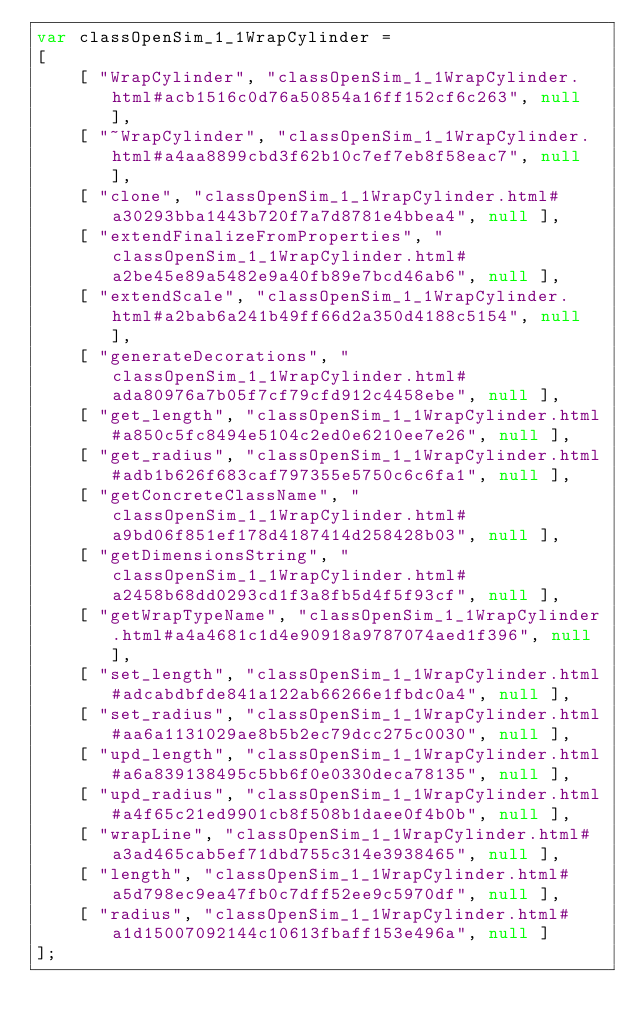<code> <loc_0><loc_0><loc_500><loc_500><_JavaScript_>var classOpenSim_1_1WrapCylinder =
[
    [ "WrapCylinder", "classOpenSim_1_1WrapCylinder.html#acb1516c0d76a50854a16ff152cf6c263", null ],
    [ "~WrapCylinder", "classOpenSim_1_1WrapCylinder.html#a4aa8899cbd3f62b10c7ef7eb8f58eac7", null ],
    [ "clone", "classOpenSim_1_1WrapCylinder.html#a30293bba1443b720f7a7d8781e4bbea4", null ],
    [ "extendFinalizeFromProperties", "classOpenSim_1_1WrapCylinder.html#a2be45e89a5482e9a40fb89e7bcd46ab6", null ],
    [ "extendScale", "classOpenSim_1_1WrapCylinder.html#a2bab6a241b49ff66d2a350d4188c5154", null ],
    [ "generateDecorations", "classOpenSim_1_1WrapCylinder.html#ada80976a7b05f7cf79cfd912c4458ebe", null ],
    [ "get_length", "classOpenSim_1_1WrapCylinder.html#a850c5fc8494e5104c2ed0e6210ee7e26", null ],
    [ "get_radius", "classOpenSim_1_1WrapCylinder.html#adb1b626f683caf797355e5750c6c6fa1", null ],
    [ "getConcreteClassName", "classOpenSim_1_1WrapCylinder.html#a9bd06f851ef178d4187414d258428b03", null ],
    [ "getDimensionsString", "classOpenSim_1_1WrapCylinder.html#a2458b68dd0293cd1f3a8fb5d4f5f93cf", null ],
    [ "getWrapTypeName", "classOpenSim_1_1WrapCylinder.html#a4a4681c1d4e90918a9787074aed1f396", null ],
    [ "set_length", "classOpenSim_1_1WrapCylinder.html#adcabdbfde841a122ab66266e1fbdc0a4", null ],
    [ "set_radius", "classOpenSim_1_1WrapCylinder.html#aa6a1131029ae8b5b2ec79dcc275c0030", null ],
    [ "upd_length", "classOpenSim_1_1WrapCylinder.html#a6a839138495c5bb6f0e0330deca78135", null ],
    [ "upd_radius", "classOpenSim_1_1WrapCylinder.html#a4f65c21ed9901cb8f508b1daee0f4b0b", null ],
    [ "wrapLine", "classOpenSim_1_1WrapCylinder.html#a3ad465cab5ef71dbd755c314e3938465", null ],
    [ "length", "classOpenSim_1_1WrapCylinder.html#a5d798ec9ea47fb0c7dff52ee9c5970df", null ],
    [ "radius", "classOpenSim_1_1WrapCylinder.html#a1d15007092144c10613fbaff153e496a", null ]
];</code> 